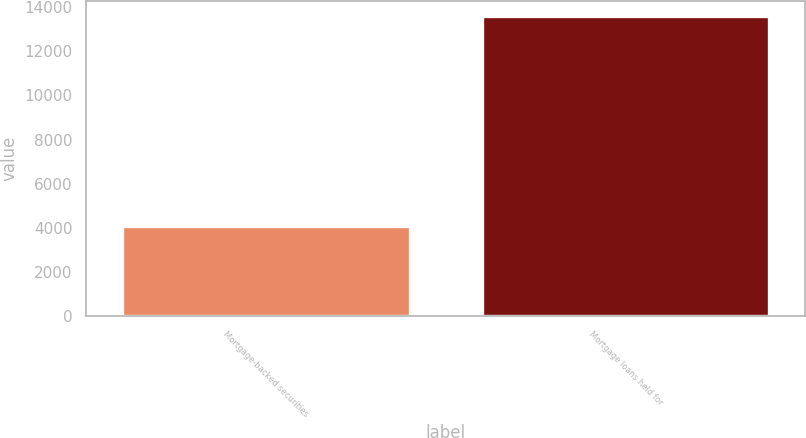Convert chart. <chart><loc_0><loc_0><loc_500><loc_500><bar_chart><fcel>Mortgage-backed securities<fcel>Mortgage loans held for<nl><fcel>4067<fcel>13610<nl></chart> 